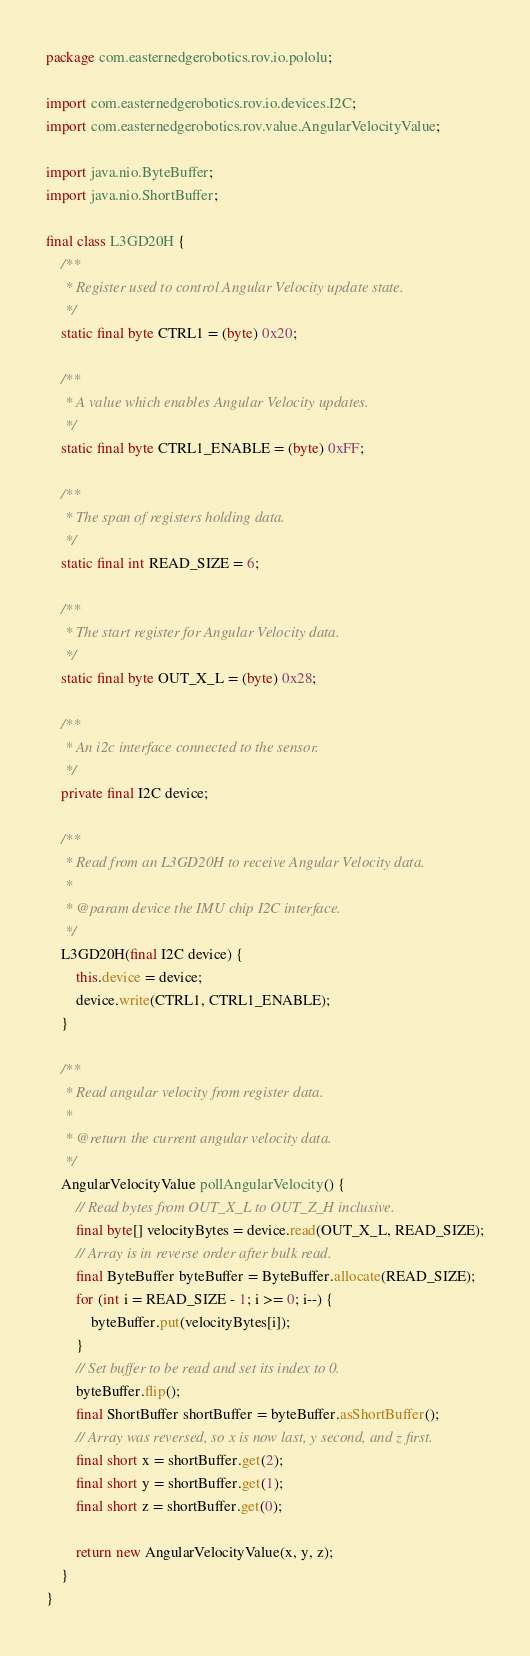<code> <loc_0><loc_0><loc_500><loc_500><_Java_>package com.easternedgerobotics.rov.io.pololu;

import com.easternedgerobotics.rov.io.devices.I2C;
import com.easternedgerobotics.rov.value.AngularVelocityValue;

import java.nio.ByteBuffer;
import java.nio.ShortBuffer;

final class L3GD20H {
    /**
     * Register used to control Angular Velocity update state.
     */
    static final byte CTRL1 = (byte) 0x20;

    /**
     * A value which enables Angular Velocity updates.
     */
    static final byte CTRL1_ENABLE = (byte) 0xFF;

    /**
     * The span of registers holding data.
     */
    static final int READ_SIZE = 6;

    /**
     * The start register for Angular Velocity data.
     */
    static final byte OUT_X_L = (byte) 0x28;

    /**
     * An i2c interface connected to the sensor.
     */
    private final I2C device;

    /**
     * Read from an L3GD20H to receive Angular Velocity data.
     *
     * @param device the IMU chip I2C interface.
     */
    L3GD20H(final I2C device) {
        this.device = device;
        device.write(CTRL1, CTRL1_ENABLE);
    }

    /**
     * Read angular velocity from register data.
     *
     * @return the current angular velocity data.
     */
    AngularVelocityValue pollAngularVelocity() {
        // Read bytes from OUT_X_L to OUT_Z_H inclusive.
        final byte[] velocityBytes = device.read(OUT_X_L, READ_SIZE);
        // Array is in reverse order after bulk read.
        final ByteBuffer byteBuffer = ByteBuffer.allocate(READ_SIZE);
        for (int i = READ_SIZE - 1; i >= 0; i--) {
            byteBuffer.put(velocityBytes[i]);
        }
        // Set buffer to be read and set its index to 0.
        byteBuffer.flip();
        final ShortBuffer shortBuffer = byteBuffer.asShortBuffer();
        // Array was reversed, so x is now last, y second, and z first.
        final short x = shortBuffer.get(2);
        final short y = shortBuffer.get(1);
        final short z = shortBuffer.get(0);

        return new AngularVelocityValue(x, y, z);
    }
}
</code> 